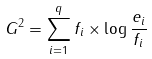Convert formula to latex. <formula><loc_0><loc_0><loc_500><loc_500>G ^ { 2 } = \sum _ { i = 1 } ^ { q } f _ { i } \times \log \frac { e _ { i } } { f _ { i } }</formula> 